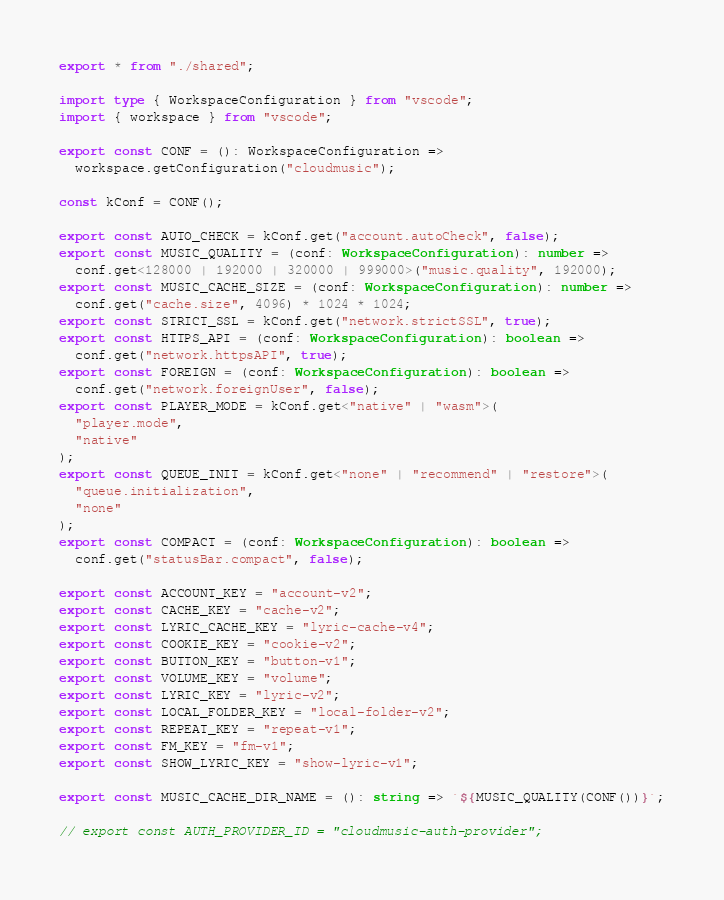<code> <loc_0><loc_0><loc_500><loc_500><_TypeScript_>export * from "./shared";

import type { WorkspaceConfiguration } from "vscode";
import { workspace } from "vscode";

export const CONF = (): WorkspaceConfiguration =>
  workspace.getConfiguration("cloudmusic");

const kConf = CONF();

export const AUTO_CHECK = kConf.get("account.autoCheck", false);
export const MUSIC_QUALITY = (conf: WorkspaceConfiguration): number =>
  conf.get<128000 | 192000 | 320000 | 999000>("music.quality", 192000);
export const MUSIC_CACHE_SIZE = (conf: WorkspaceConfiguration): number =>
  conf.get("cache.size", 4096) * 1024 * 1024;
export const STRICT_SSL = kConf.get("network.strictSSL", true);
export const HTTPS_API = (conf: WorkspaceConfiguration): boolean =>
  conf.get("network.httpsAPI", true);
export const FOREIGN = (conf: WorkspaceConfiguration): boolean =>
  conf.get("network.foreignUser", false);
export const PLAYER_MODE = kConf.get<"native" | "wasm">(
  "player.mode",
  "native"
);
export const QUEUE_INIT = kConf.get<"none" | "recommend" | "restore">(
  "queue.initialization",
  "none"
);
export const COMPACT = (conf: WorkspaceConfiguration): boolean =>
  conf.get("statusBar.compact", false);

export const ACCOUNT_KEY = "account-v2";
export const CACHE_KEY = "cache-v2";
export const LYRIC_CACHE_KEY = "lyric-cache-v4";
export const COOKIE_KEY = "cookie-v2";
export const BUTTON_KEY = "button-v1";
export const VOLUME_KEY = "volume";
export const LYRIC_KEY = "lyric-v2";
export const LOCAL_FOLDER_KEY = "local-folder-v2";
export const REPEAT_KEY = "repeat-v1";
export const FM_KEY = "fm-v1";
export const SHOW_LYRIC_KEY = "show-lyric-v1";

export const MUSIC_CACHE_DIR_NAME = (): string => `${MUSIC_QUALITY(CONF())}`;

// export const AUTH_PROVIDER_ID = "cloudmusic-auth-provider";
</code> 